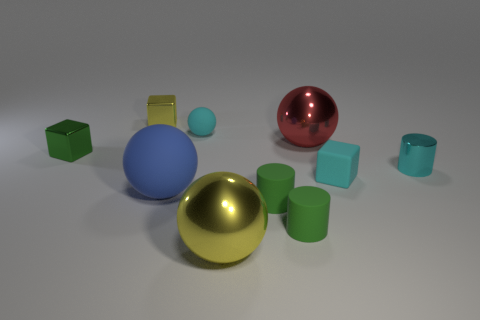There is a large yellow thing; what shape is it?
Keep it short and to the point. Sphere. Is there any other thing that is made of the same material as the cyan cylinder?
Offer a very short reply. Yes. Do the blue object and the small ball have the same material?
Ensure brevity in your answer.  Yes. Is there a yellow ball that is behind the matte thing that is behind the tiny green cube that is in front of the red ball?
Your response must be concise. No. What number of other objects are the same shape as the big blue matte object?
Provide a succinct answer. 3. What shape is the large object that is behind the yellow shiny ball and in front of the tiny cyan cube?
Your response must be concise. Sphere. The tiny matte object behind the small cylinder on the right side of the large metallic object that is behind the big blue rubber sphere is what color?
Offer a very short reply. Cyan. Is the number of balls to the right of the blue object greater than the number of metallic cylinders behind the yellow cube?
Provide a succinct answer. Yes. How many other things are the same size as the green cube?
Give a very brief answer. 6. There is a tiny cube that is in front of the tiny cylinder behind the blue matte thing; what is its material?
Provide a short and direct response. Rubber. 